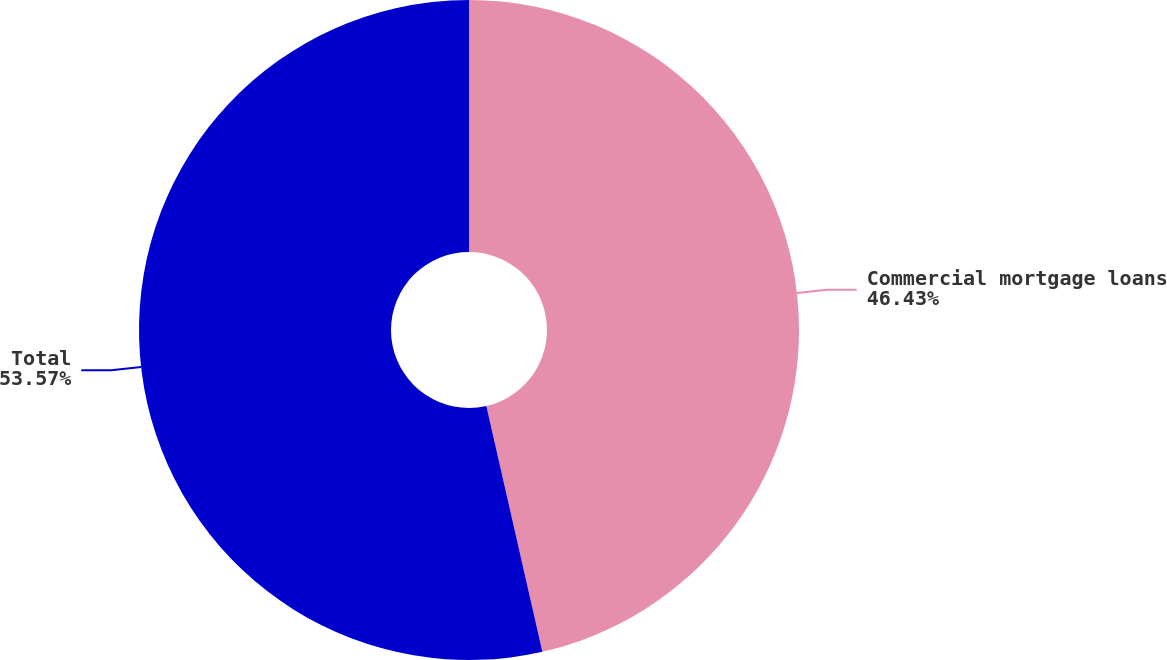<chart> <loc_0><loc_0><loc_500><loc_500><pie_chart><fcel>Commercial mortgage loans<fcel>Total<nl><fcel>46.43%<fcel>53.57%<nl></chart> 